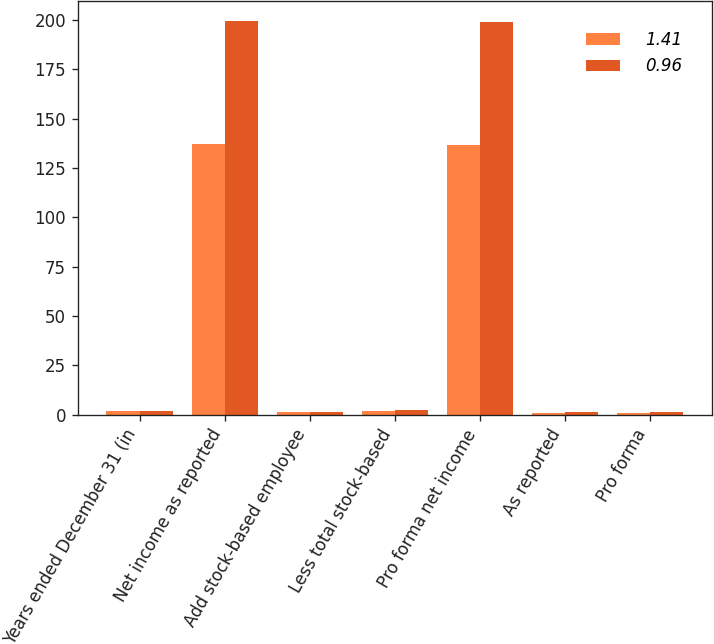<chart> <loc_0><loc_0><loc_500><loc_500><stacked_bar_chart><ecel><fcel>Years ended December 31 (in<fcel>Net income as reported<fcel>Add stock-based employee<fcel>Less total stock-based<fcel>Pro forma net income<fcel>As reported<fcel>Pro forma<nl><fcel>1.41<fcel>1.665<fcel>137.1<fcel>1.4<fcel>1.9<fcel>136.6<fcel>0.97<fcel>0.97<nl><fcel>0.96<fcel>1.665<fcel>199.7<fcel>1.4<fcel>2.1<fcel>199<fcel>1.43<fcel>1.42<nl></chart> 